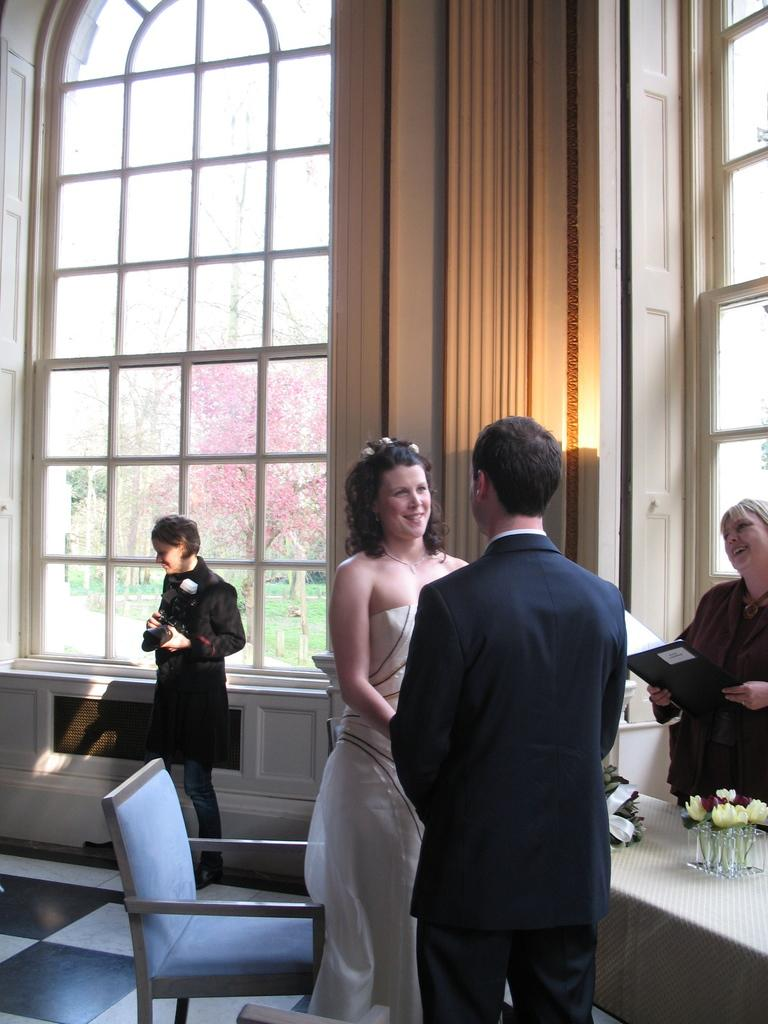What can be seen in the image? There are people standing in the image. Are there any objects present in the image? Yes, there is a chair in the image. How are the people in the image feeling? Some people have smiles on their faces, which suggests they are happy or enjoying themselves. What type of bun is being used as a hat by one of the people in the image? There is no bun or hat present in the image; the people are not wearing any headgear. 